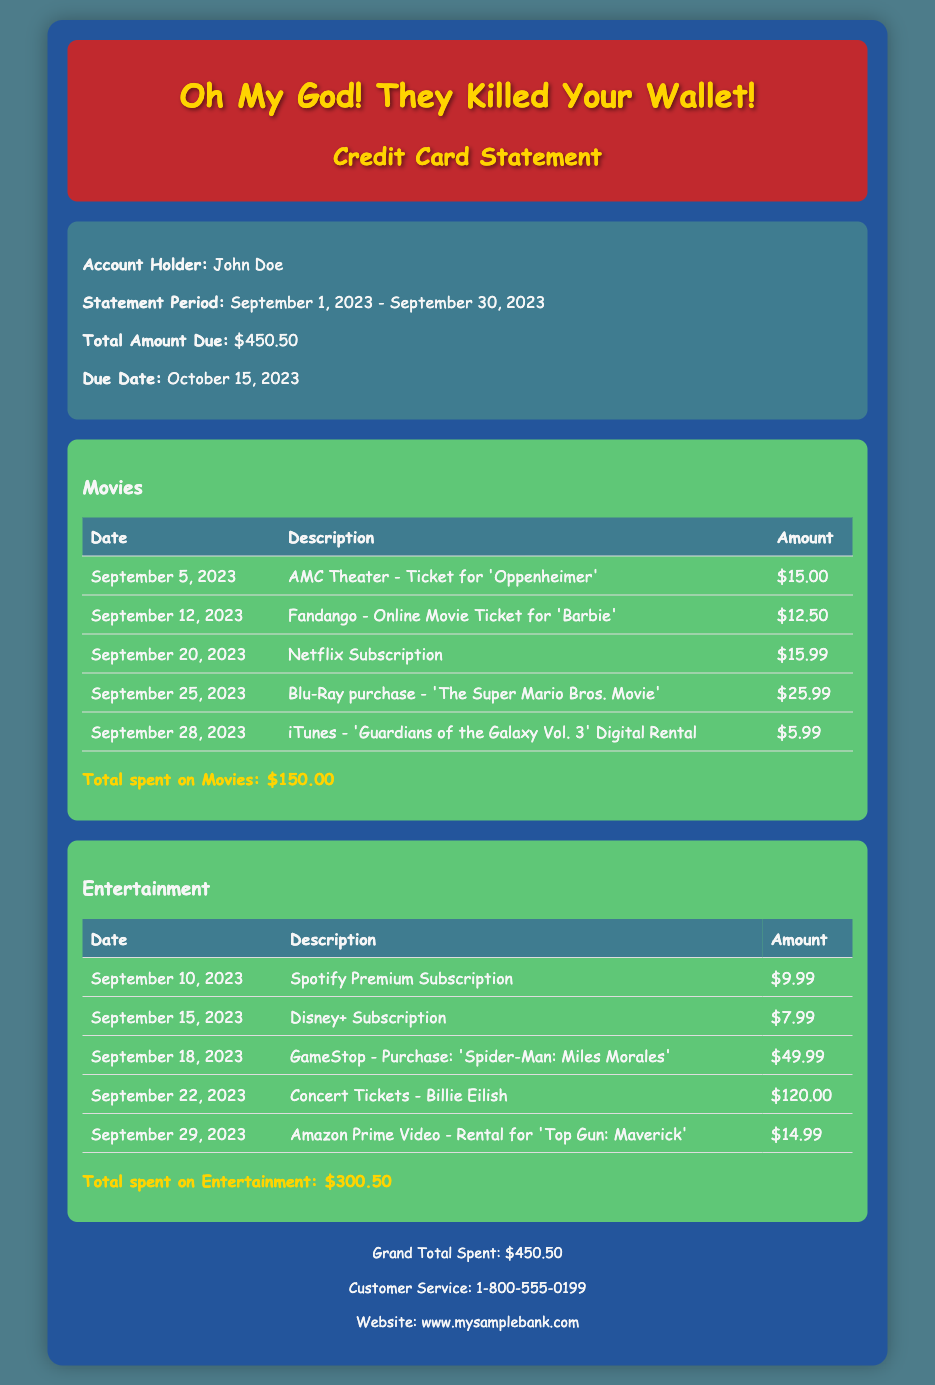what is the total amount due? The total amount due is clearly stated in the summary section of the document.
Answer: $450.50 who is the account holder? The account holder’s name is presented in the summary section of the document.
Answer: John Doe what was the amount spent on concert tickets? The amount spent on concert tickets is summarized in the Entertainment category table.
Answer: $120.00 which movie had a ticket purchase on September 5, 2023? The specific ticket purchase for the date September 5, 2023, is shown in the Movies category table.
Answer: 'Oppenheimer' how many purchases related to movies are listed? To find the number of movie-related purchases, count the rows in the Movies table, excluding the header.
Answer: 5 what is the total spent on entertainment? The total spent on entertainment is provided at the end of the Entertainment category section.
Answer: $300.50 what is the due date for the payment? The due date is mentioned in the summary section of the document.
Answer: October 15, 2023 which streaming service subscription appears on the statement? The document lists two streaming service subscriptions; the question refers to just one of them provided in the Entertainment category.
Answer: Netflix Subscription what was the purpose of the purchase on September 22, 2023? The purpose of the purchase is described in the Entertainment category table for that date.
Answer: Concert Tickets - Billie Eilish 